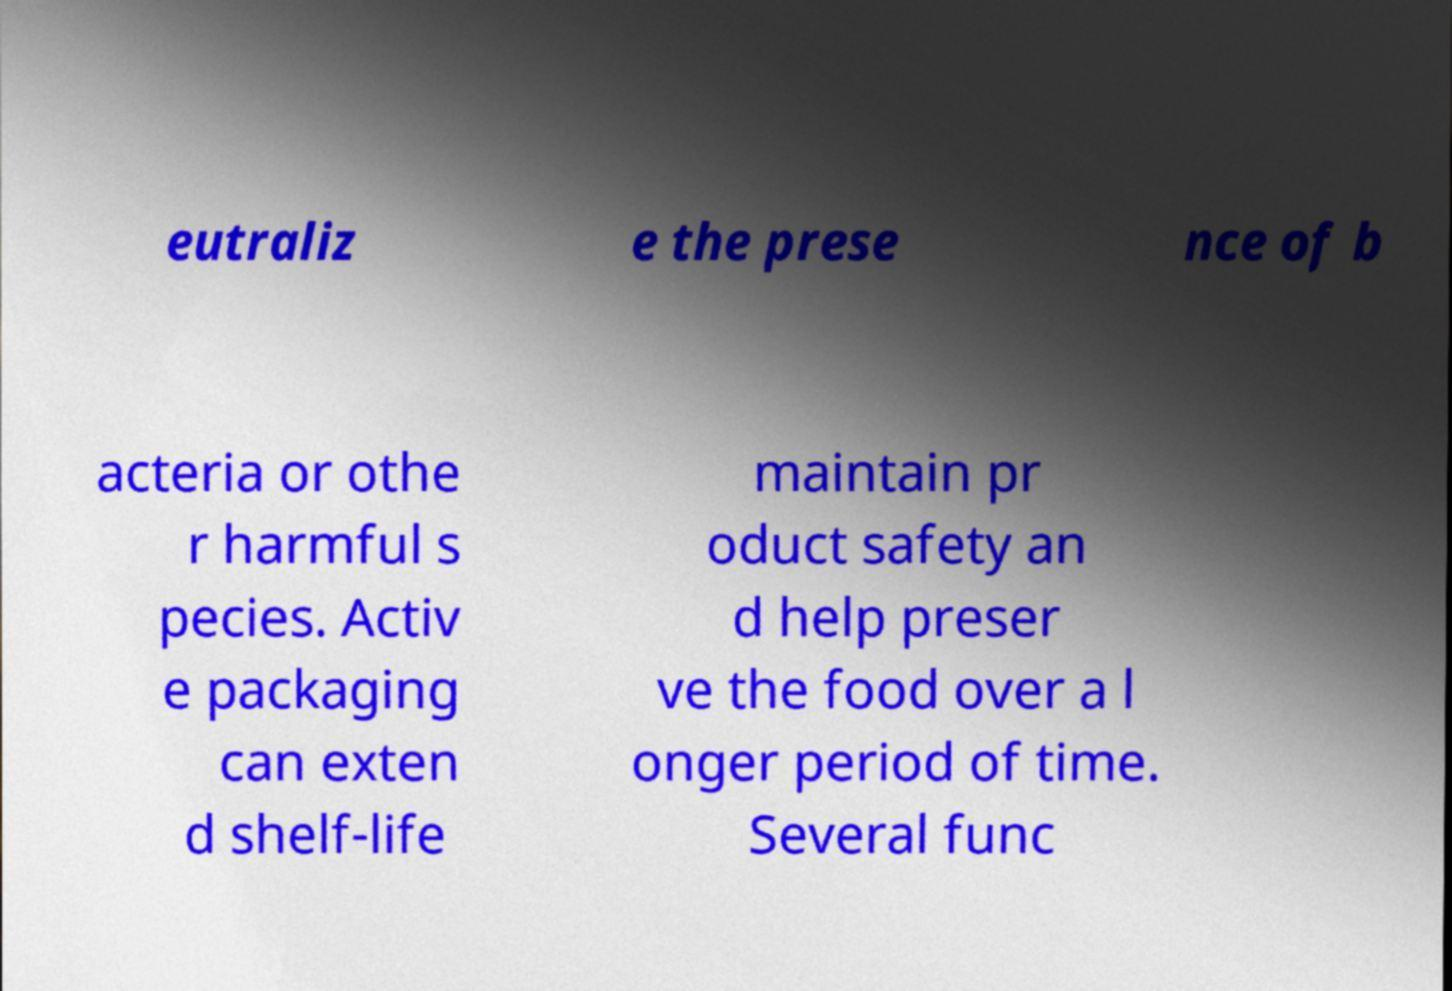Can you accurately transcribe the text from the provided image for me? eutraliz e the prese nce of b acteria or othe r harmful s pecies. Activ e packaging can exten d shelf-life maintain pr oduct safety an d help preser ve the food over a l onger period of time. Several func 